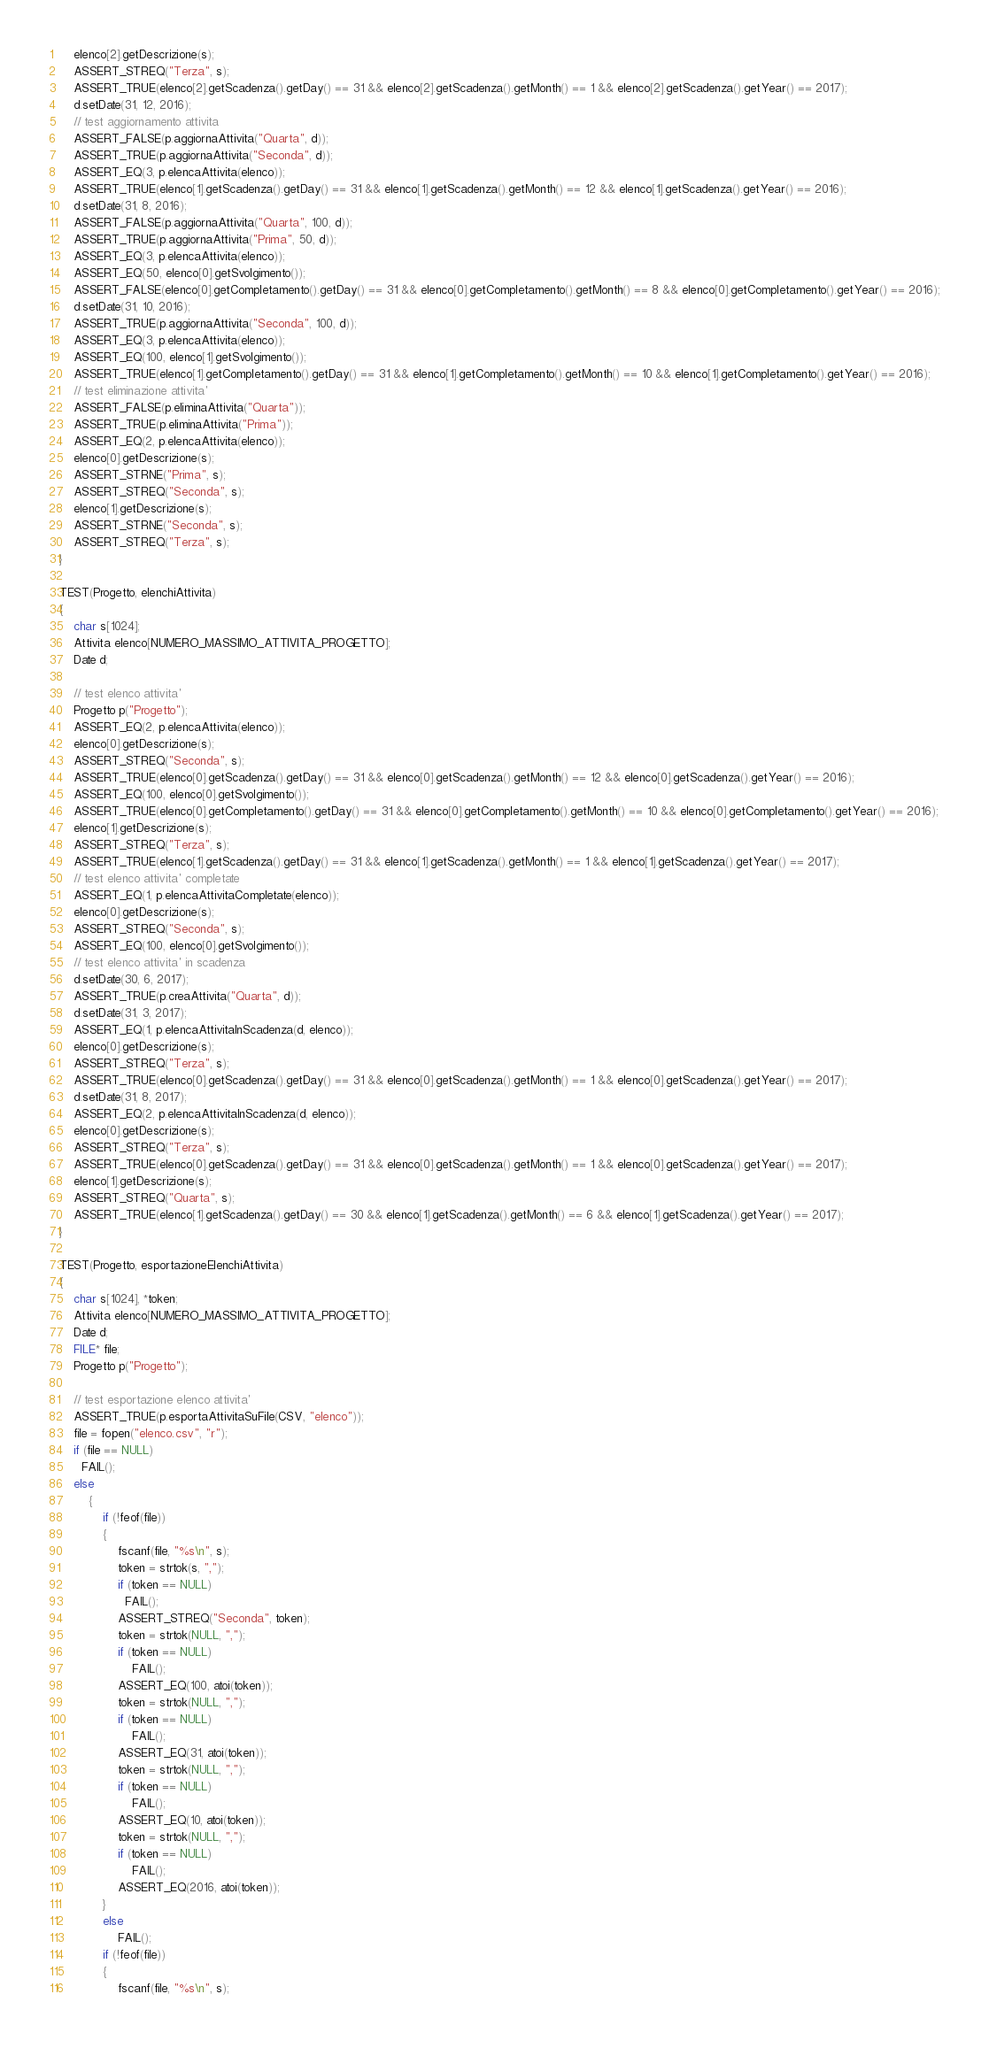Convert code to text. <code><loc_0><loc_0><loc_500><loc_500><_C++_>	elenco[2].getDescrizione(s);
	ASSERT_STREQ("Terza", s);
	ASSERT_TRUE(elenco[2].getScadenza().getDay() == 31 && elenco[2].getScadenza().getMonth() == 1 && elenco[2].getScadenza().getYear() == 2017);
	d.setDate(31, 12, 2016);
	// test aggiornamento attivita
	ASSERT_FALSE(p.aggiornaAttivita("Quarta", d));
	ASSERT_TRUE(p.aggiornaAttivita("Seconda", d));
	ASSERT_EQ(3, p.elencaAttivita(elenco));
	ASSERT_TRUE(elenco[1].getScadenza().getDay() == 31 && elenco[1].getScadenza().getMonth() == 12 && elenco[1].getScadenza().getYear() == 2016);
	d.setDate(31, 8, 2016);
	ASSERT_FALSE(p.aggiornaAttivita("Quarta", 100, d));
	ASSERT_TRUE(p.aggiornaAttivita("Prima", 50, d));
	ASSERT_EQ(3, p.elencaAttivita(elenco));
	ASSERT_EQ(50, elenco[0].getSvolgimento());
	ASSERT_FALSE(elenco[0].getCompletamento().getDay() == 31 && elenco[0].getCompletamento().getMonth() == 8 && elenco[0].getCompletamento().getYear() == 2016);
	d.setDate(31, 10, 2016);
	ASSERT_TRUE(p.aggiornaAttivita("Seconda", 100, d));
	ASSERT_EQ(3, p.elencaAttivita(elenco));
	ASSERT_EQ(100, elenco[1].getSvolgimento());
	ASSERT_TRUE(elenco[1].getCompletamento().getDay() == 31 && elenco[1].getCompletamento().getMonth() == 10 && elenco[1].getCompletamento().getYear() == 2016);
	// test eliminazione attivita'
	ASSERT_FALSE(p.eliminaAttivita("Quarta"));
	ASSERT_TRUE(p.eliminaAttivita("Prima"));
	ASSERT_EQ(2, p.elencaAttivita(elenco));
	elenco[0].getDescrizione(s);
	ASSERT_STRNE("Prima", s);
	ASSERT_STREQ("Seconda", s);
	elenco[1].getDescrizione(s);
	ASSERT_STRNE("Seconda", s);
	ASSERT_STREQ("Terza", s);
}

TEST(Progetto, elenchiAttivita)
{
	char s[1024];
	Attivita elenco[NUMERO_MASSIMO_ATTIVITA_PROGETTO];
	Date d;

	// test elenco attivita'
	Progetto p("Progetto");
	ASSERT_EQ(2, p.elencaAttivita(elenco));
	elenco[0].getDescrizione(s);
	ASSERT_STREQ("Seconda", s);
	ASSERT_TRUE(elenco[0].getScadenza().getDay() == 31 && elenco[0].getScadenza().getMonth() == 12 && elenco[0].getScadenza().getYear() == 2016);
	ASSERT_EQ(100, elenco[0].getSvolgimento());
	ASSERT_TRUE(elenco[0].getCompletamento().getDay() == 31 && elenco[0].getCompletamento().getMonth() == 10 && elenco[0].getCompletamento().getYear() == 2016);
	elenco[1].getDescrizione(s);
	ASSERT_STREQ("Terza", s);
	ASSERT_TRUE(elenco[1].getScadenza().getDay() == 31 && elenco[1].getScadenza().getMonth() == 1 && elenco[1].getScadenza().getYear() == 2017);
	// test elenco attivita' completate
	ASSERT_EQ(1, p.elencaAttivitaCompletate(elenco));
	elenco[0].getDescrizione(s);
	ASSERT_STREQ("Seconda", s);
	ASSERT_EQ(100, elenco[0].getSvolgimento());
	// test elenco attivita' in scadenza
	d.setDate(30, 6, 2017);
	ASSERT_TRUE(p.creaAttivita("Quarta", d));
	d.setDate(31, 3, 2017);
	ASSERT_EQ(1, p.elencaAttivitaInScadenza(d, elenco));
	elenco[0].getDescrizione(s);
	ASSERT_STREQ("Terza", s);
	ASSERT_TRUE(elenco[0].getScadenza().getDay() == 31 && elenco[0].getScadenza().getMonth() == 1 && elenco[0].getScadenza().getYear() == 2017);
	d.setDate(31, 8, 2017);
	ASSERT_EQ(2, p.elencaAttivitaInScadenza(d, elenco));
	elenco[0].getDescrizione(s);
	ASSERT_STREQ("Terza", s);
	ASSERT_TRUE(elenco[0].getScadenza().getDay() == 31 && elenco[0].getScadenza().getMonth() == 1 && elenco[0].getScadenza().getYear() == 2017);
	elenco[1].getDescrizione(s);
	ASSERT_STREQ("Quarta", s);
	ASSERT_TRUE(elenco[1].getScadenza().getDay() == 30 && elenco[1].getScadenza().getMonth() == 6 && elenco[1].getScadenza().getYear() == 2017);
}

TEST(Progetto, esportazioneElenchiAttivita)
{
	char s[1024], *token;
	Attivita elenco[NUMERO_MASSIMO_ATTIVITA_PROGETTO];
	Date d;
	FILE* file;
	Progetto p("Progetto");
	
	// test esportazione elenco attivita'
	ASSERT_TRUE(p.esportaAttivitaSuFile(CSV, "elenco"));
	file = fopen("elenco.csv", "r");
	if (file == NULL)
	  FAIL();
	else
	    {
			if (!feof(file))
			{
				fscanf(file, "%s\n", s);
				token = strtok(s, ",");
				if (token == NULL)
				  FAIL();
				ASSERT_STREQ("Seconda", token);
				token = strtok(NULL, ",");
				if (token == NULL)
					FAIL();
				ASSERT_EQ(100, atoi(token));
				token = strtok(NULL, ",");
				if (token == NULL)
					FAIL();
				ASSERT_EQ(31, atoi(token));
				token = strtok(NULL, ",");
				if (token == NULL)
					FAIL();
				ASSERT_EQ(10, atoi(token));
				token = strtok(NULL, ",");
				if (token == NULL)
					FAIL();
				ASSERT_EQ(2016, atoi(token));
			}
			else
				FAIL();
			if (!feof(file))
			{
				fscanf(file, "%s\n", s);</code> 